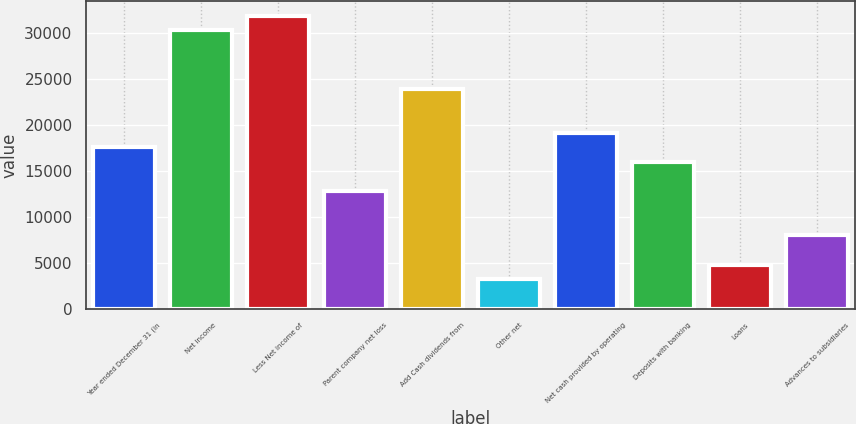<chart> <loc_0><loc_0><loc_500><loc_500><bar_chart><fcel>Year ended December 31 (in<fcel>Net income<fcel>Less Net income of<fcel>Parent company net loss<fcel>Add Cash dividends from<fcel>Other net<fcel>Net cash provided by operating<fcel>Deposits with banking<fcel>Loans<fcel>Advances to subsidiaries<nl><fcel>17586<fcel>30338<fcel>31932<fcel>12804<fcel>23962<fcel>3240<fcel>19180<fcel>15992<fcel>4834<fcel>8022<nl></chart> 